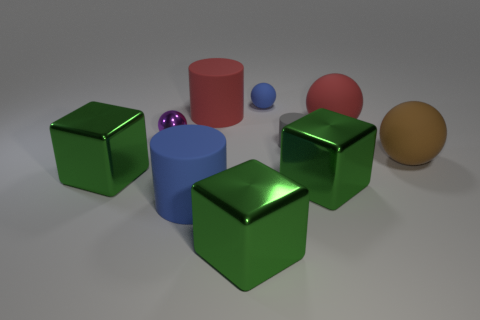Subtract all green cubes. How many were subtracted if there are1green cubes left? 2 Subtract all blue matte spheres. How many spheres are left? 3 Subtract all purple balls. How many balls are left? 3 Subtract all yellow cylinders. Subtract all yellow blocks. How many cylinders are left? 3 Subtract all balls. How many objects are left? 6 Subtract 0 green spheres. How many objects are left? 10 Subtract all tiny blue balls. Subtract all red rubber balls. How many objects are left? 8 Add 1 red cylinders. How many red cylinders are left? 2 Add 2 cyan blocks. How many cyan blocks exist? 2 